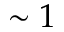<formula> <loc_0><loc_0><loc_500><loc_500>\sim 1</formula> 